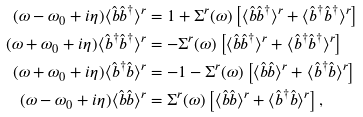Convert formula to latex. <formula><loc_0><loc_0><loc_500><loc_500>( \omega - \omega _ { 0 } + i \eta ) \langle \hat { b } \hat { b } ^ { \dagger } \rangle ^ { r } & = 1 + \Sigma ^ { r } ( \omega ) \left [ \langle \hat { b } \hat { b } ^ { \dagger } \rangle ^ { r } + \langle \hat { b } ^ { \dagger } \hat { b } ^ { \dagger } \rangle ^ { r } \right ] \\ ( \omega + \omega _ { 0 } + i \eta ) \langle \hat { b } ^ { \dagger } \hat { b } ^ { \dagger } \rangle ^ { r } & = - \Sigma ^ { r } ( \omega ) \left [ \langle \hat { b } \hat { b } ^ { \dagger } \rangle ^ { r } + \langle \hat { b } ^ { \dagger } \hat { b } ^ { \dagger } \rangle ^ { r } \right ] \\ ( \omega + \omega _ { 0 } + i \eta ) \langle \hat { b } ^ { \dagger } \hat { b } \rangle ^ { r } & = - 1 - \Sigma ^ { r } ( \omega ) \left [ \langle \hat { b } \hat { b } \rangle ^ { r } + \langle \hat { b } ^ { \dagger } \hat { b } \rangle ^ { r } \right ] \\ ( \omega - \omega _ { 0 } + i \eta ) \langle \hat { b } \hat { b } \rangle ^ { r } & = \Sigma ^ { r } ( \omega ) \left [ \langle \hat { b } \hat { b } \rangle ^ { r } + \langle \hat { b } ^ { \dagger } \hat { b } \rangle ^ { r } \right ] ,</formula> 